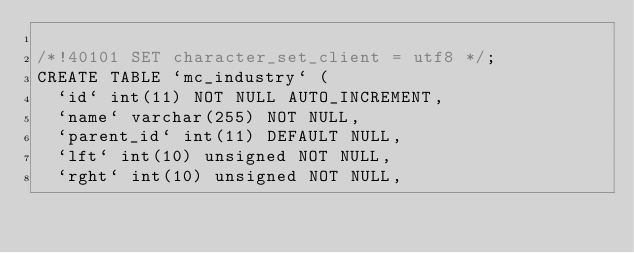Convert code to text. <code><loc_0><loc_0><loc_500><loc_500><_SQL_>
/*!40101 SET character_set_client = utf8 */;
CREATE TABLE `mc_industry` (
  `id` int(11) NOT NULL AUTO_INCREMENT,
  `name` varchar(255) NOT NULL,
  `parent_id` int(11) DEFAULT NULL,
  `lft` int(10) unsigned NOT NULL,
  `rght` int(10) unsigned NOT NULL,</code> 